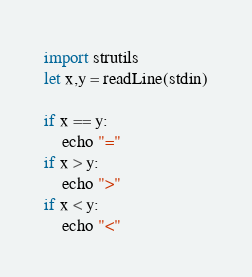<code> <loc_0><loc_0><loc_500><loc_500><_Nim_>import strutils
let x,y = readLine(stdin)

if x == y:
    echo "="
if x > y:
    echo ">"
if x < y:
    echo "<"</code> 